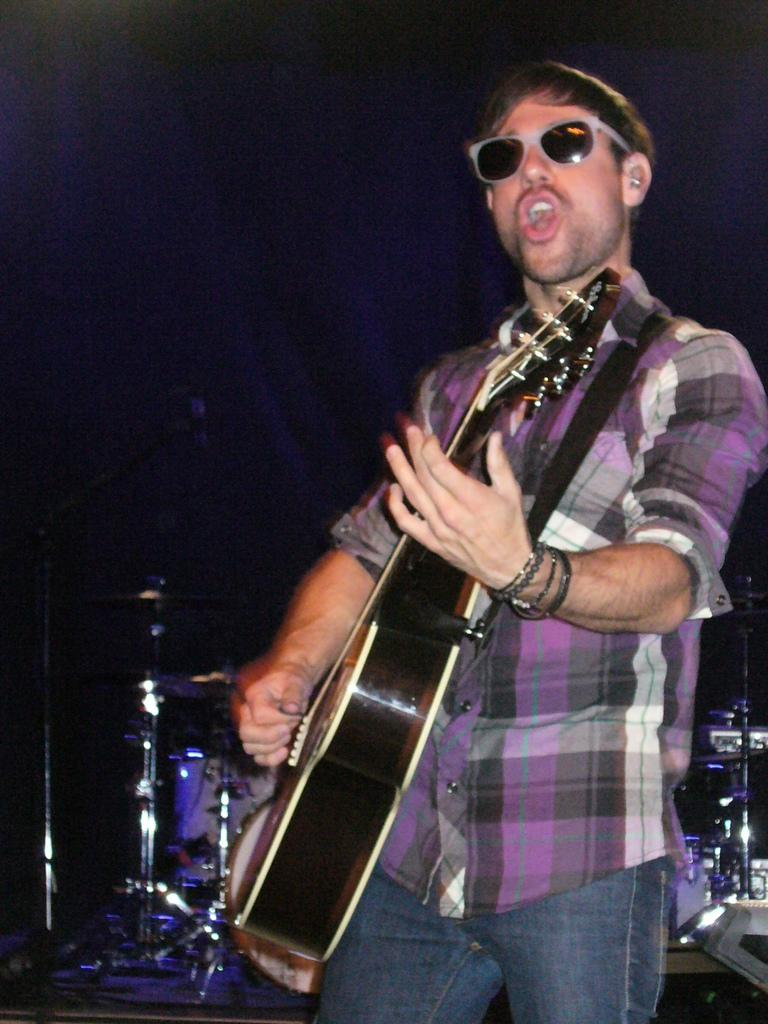What is the main subject of the image? There is a person in the image. What is the person doing in the image? The person is standing and playing a guitar. Are there any other musical instruments in the image? Yes, there are musical instruments at the back of the person. What is the person wearing on their face? The person is wearing goggles. What is the person holding in their hand? The person has a bracelet in their hand. What color is the paint on the person's brush in the image? There is no paint or brush present in the image; the person is playing a guitar and wearing goggles. 